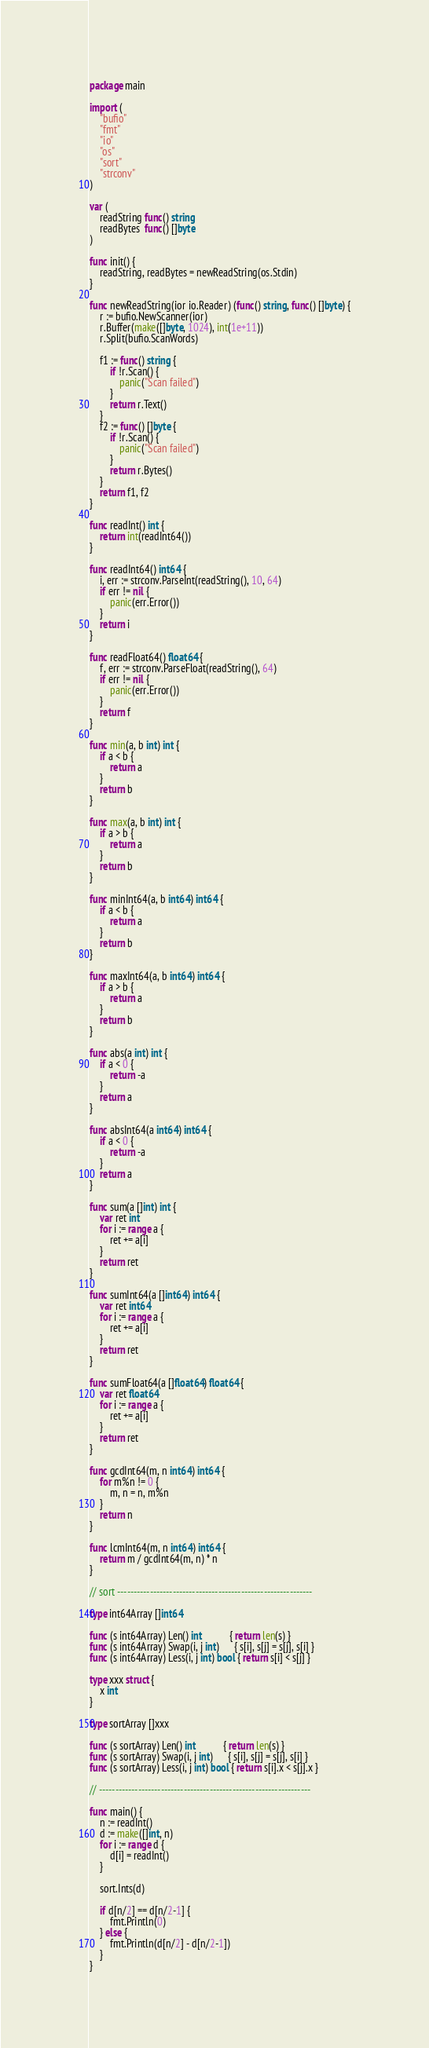<code> <loc_0><loc_0><loc_500><loc_500><_Go_>package main

import (
	"bufio"
	"fmt"
	"io"
	"os"
	"sort"
	"strconv"
)

var (
	readString func() string
	readBytes  func() []byte
)

func init() {
	readString, readBytes = newReadString(os.Stdin)
}

func newReadString(ior io.Reader) (func() string, func() []byte) {
	r := bufio.NewScanner(ior)
	r.Buffer(make([]byte, 1024), int(1e+11))
	r.Split(bufio.ScanWords)

	f1 := func() string {
		if !r.Scan() {
			panic("Scan failed")
		}
		return r.Text()
	}
	f2 := func() []byte {
		if !r.Scan() {
			panic("Scan failed")
		}
		return r.Bytes()
	}
	return f1, f2
}

func readInt() int {
	return int(readInt64())
}

func readInt64() int64 {
	i, err := strconv.ParseInt(readString(), 10, 64)
	if err != nil {
		panic(err.Error())
	}
	return i
}

func readFloat64() float64 {
	f, err := strconv.ParseFloat(readString(), 64)
	if err != nil {
		panic(err.Error())
	}
	return f
}

func min(a, b int) int {
	if a < b {
		return a
	}
	return b
}

func max(a, b int) int {
	if a > b {
		return a
	}
	return b
}

func minInt64(a, b int64) int64 {
	if a < b {
		return a
	}
	return b
}

func maxInt64(a, b int64) int64 {
	if a > b {
		return a
	}
	return b
}

func abs(a int) int {
	if a < 0 {
		return -a
	}
	return a
}

func absInt64(a int64) int64 {
	if a < 0 {
		return -a
	}
	return a
}

func sum(a []int) int {
	var ret int
	for i := range a {
		ret += a[i]
	}
	return ret
}

func sumInt64(a []int64) int64 {
	var ret int64
	for i := range a {
		ret += a[i]
	}
	return ret
}

func sumFloat64(a []float64) float64 {
	var ret float64
	for i := range a {
		ret += a[i]
	}
	return ret
}

func gcdInt64(m, n int64) int64 {
	for m%n != 0 {
		m, n = n, m%n
	}
	return n
}

func lcmInt64(m, n int64) int64 {
	return m / gcdInt64(m, n) * n
}

// sort ------------------------------------------------------------

type int64Array []int64

func (s int64Array) Len() int           { return len(s) }
func (s int64Array) Swap(i, j int)      { s[i], s[j] = s[j], s[i] }
func (s int64Array) Less(i, j int) bool { return s[i] < s[j] }

type xxx struct {
	x int
}

type sortArray []xxx

func (s sortArray) Len() int           { return len(s) }
func (s sortArray) Swap(i, j int)      { s[i], s[j] = s[j], s[i] }
func (s sortArray) Less(i, j int) bool { return s[i].x < s[j].x }

// -----------------------------------------------------------------

func main() {
	n := readInt()
	d := make([]int, n)
	for i := range d {
		d[i] = readInt()
	}

	sort.Ints(d)

	if d[n/2] == d[n/2-1] {
		fmt.Println(0)
	} else {
		fmt.Println(d[n/2] - d[n/2-1])
	}
}
</code> 